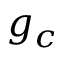Convert formula to latex. <formula><loc_0><loc_0><loc_500><loc_500>g _ { c }</formula> 